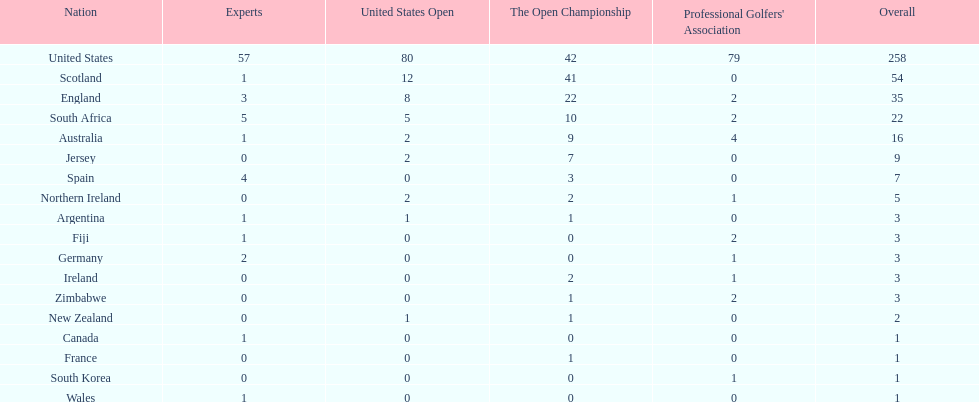How many total championships does spain have? 7. 